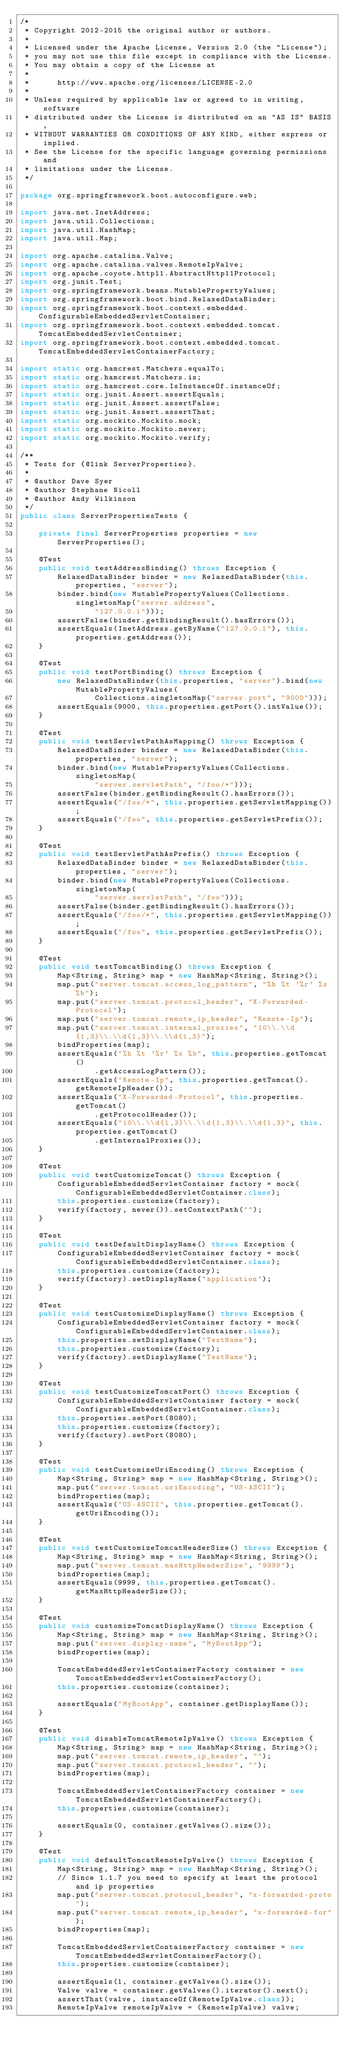Convert code to text. <code><loc_0><loc_0><loc_500><loc_500><_Java_>/*
 * Copyright 2012-2015 the original author or authors.
 *
 * Licensed under the Apache License, Version 2.0 (the "License");
 * you may not use this file except in compliance with the License.
 * You may obtain a copy of the License at
 *
 *      http://www.apache.org/licenses/LICENSE-2.0
 *
 * Unless required by applicable law or agreed to in writing, software
 * distributed under the License is distributed on an "AS IS" BASIS,
 * WITHOUT WARRANTIES OR CONDITIONS OF ANY KIND, either express or implied.
 * See the License for the specific language governing permissions and
 * limitations under the License.
 */

package org.springframework.boot.autoconfigure.web;

import java.net.InetAddress;
import java.util.Collections;
import java.util.HashMap;
import java.util.Map;

import org.apache.catalina.Valve;
import org.apache.catalina.valves.RemoteIpValve;
import org.apache.coyote.http11.AbstractHttp11Protocol;
import org.junit.Test;
import org.springframework.beans.MutablePropertyValues;
import org.springframework.boot.bind.RelaxedDataBinder;
import org.springframework.boot.context.embedded.ConfigurableEmbeddedServletContainer;
import org.springframework.boot.context.embedded.tomcat.TomcatEmbeddedServletContainer;
import org.springframework.boot.context.embedded.tomcat.TomcatEmbeddedServletContainerFactory;

import static org.hamcrest.Matchers.equalTo;
import static org.hamcrest.Matchers.is;
import static org.hamcrest.core.IsInstanceOf.instanceOf;
import static org.junit.Assert.assertEquals;
import static org.junit.Assert.assertFalse;
import static org.junit.Assert.assertThat;
import static org.mockito.Mockito.mock;
import static org.mockito.Mockito.never;
import static org.mockito.Mockito.verify;

/**
 * Tests for {@link ServerProperties}.
 *
 * @author Dave Syer
 * @author Stephane Nicoll
 * @author Andy Wilkinson
 */
public class ServerPropertiesTests {

	private final ServerProperties properties = new ServerProperties();

	@Test
	public void testAddressBinding() throws Exception {
		RelaxedDataBinder binder = new RelaxedDataBinder(this.properties, "server");
		binder.bind(new MutablePropertyValues(Collections.singletonMap("server.address",
				"127.0.0.1")));
		assertFalse(binder.getBindingResult().hasErrors());
		assertEquals(InetAddress.getByName("127.0.0.1"), this.properties.getAddress());
	}

	@Test
	public void testPortBinding() throws Exception {
		new RelaxedDataBinder(this.properties, "server").bind(new MutablePropertyValues(
				Collections.singletonMap("server.port", "9000")));
		assertEquals(9000, this.properties.getPort().intValue());
	}

	@Test
	public void testServletPathAsMapping() throws Exception {
		RelaxedDataBinder binder = new RelaxedDataBinder(this.properties, "server");
		binder.bind(new MutablePropertyValues(Collections.singletonMap(
				"server.servletPath", "/foo/*")));
		assertFalse(binder.getBindingResult().hasErrors());
		assertEquals("/foo/*", this.properties.getServletMapping());
		assertEquals("/foo", this.properties.getServletPrefix());
	}

	@Test
	public void testServletPathAsPrefix() throws Exception {
		RelaxedDataBinder binder = new RelaxedDataBinder(this.properties, "server");
		binder.bind(new MutablePropertyValues(Collections.singletonMap(
				"server.servletPath", "/foo")));
		assertFalse(binder.getBindingResult().hasErrors());
		assertEquals("/foo/*", this.properties.getServletMapping());
		assertEquals("/foo", this.properties.getServletPrefix());
	}

	@Test
	public void testTomcatBinding() throws Exception {
		Map<String, String> map = new HashMap<String, String>();
		map.put("server.tomcat.access_log_pattern", "%h %t '%r' %s %b");
		map.put("server.tomcat.protocol_header", "X-Forwarded-Protocol");
		map.put("server.tomcat.remote_ip_header", "Remote-Ip");
		map.put("server.tomcat.internal_proxies", "10\\.\\d{1,3}\\.\\d{1,3}\\.\\d{1,3}");
		bindProperties(map);
		assertEquals("%h %t '%r' %s %b", this.properties.getTomcat()
				.getAccessLogPattern());
		assertEquals("Remote-Ip", this.properties.getTomcat().getRemoteIpHeader());
		assertEquals("X-Forwarded-Protocol", this.properties.getTomcat()
				.getProtocolHeader());
		assertEquals("10\\.\\d{1,3}\\.\\d{1,3}\\.\\d{1,3}", this.properties.getTomcat()
				.getInternalProxies());
	}

	@Test
	public void testCustomizeTomcat() throws Exception {
		ConfigurableEmbeddedServletContainer factory = mock(ConfigurableEmbeddedServletContainer.class);
		this.properties.customize(factory);
		verify(factory, never()).setContextPath("");
	}

	@Test
	public void testDefaultDisplayName() throws Exception {
		ConfigurableEmbeddedServletContainer factory = mock(ConfigurableEmbeddedServletContainer.class);
		this.properties.customize(factory);
		verify(factory).setDisplayName("application");
	}

	@Test
	public void testCustomizeDisplayName() throws Exception {
		ConfigurableEmbeddedServletContainer factory = mock(ConfigurableEmbeddedServletContainer.class);
		this.properties.setDisplayName("TestName");
		this.properties.customize(factory);
		verify(factory).setDisplayName("TestName");
	}

	@Test
	public void testCustomizeTomcatPort() throws Exception {
		ConfigurableEmbeddedServletContainer factory = mock(ConfigurableEmbeddedServletContainer.class);
		this.properties.setPort(8080);
		this.properties.customize(factory);
		verify(factory).setPort(8080);
	}

	@Test
	public void testCustomizeUriEncoding() throws Exception {
		Map<String, String> map = new HashMap<String, String>();
		map.put("server.tomcat.uriEncoding", "US-ASCII");
		bindProperties(map);
		assertEquals("US-ASCII", this.properties.getTomcat().getUriEncoding());
	}

	@Test
	public void testCustomizeTomcatHeaderSize() throws Exception {
		Map<String, String> map = new HashMap<String, String>();
		map.put("server.tomcat.maxHttpHeaderSize", "9999");
		bindProperties(map);
		assertEquals(9999, this.properties.getTomcat().getMaxHttpHeaderSize());
	}

	@Test
	public void customizeTomcatDisplayName() throws Exception {
		Map<String, String> map = new HashMap<String, String>();
		map.put("server.display-name", "MyBootApp");
		bindProperties(map);

		TomcatEmbeddedServletContainerFactory container = new TomcatEmbeddedServletContainerFactory();
		this.properties.customize(container);

		assertEquals("MyBootApp", container.getDisplayName());
	}

	@Test
	public void disableTomcatRemoteIpValve() throws Exception {
		Map<String, String> map = new HashMap<String, String>();
		map.put("server.tomcat.remote_ip_header", "");
		map.put("server.tomcat.protocol_header", "");
		bindProperties(map);

		TomcatEmbeddedServletContainerFactory container = new TomcatEmbeddedServletContainerFactory();
		this.properties.customize(container);

		assertEquals(0, container.getValves().size());
	}

	@Test
	public void defaultTomcatRemoteIpValve() throws Exception {
		Map<String, String> map = new HashMap<String, String>();
		// Since 1.1.7 you need to specify at least the protocol and ip properties
		map.put("server.tomcat.protocol_header", "x-forwarded-proto");
		map.put("server.tomcat.remote_ip_header", "x-forwarded-for");
		bindProperties(map);

		TomcatEmbeddedServletContainerFactory container = new TomcatEmbeddedServletContainerFactory();
		this.properties.customize(container);

		assertEquals(1, container.getValves().size());
		Valve valve = container.getValves().iterator().next();
		assertThat(valve, instanceOf(RemoteIpValve.class));
		RemoteIpValve remoteIpValve = (RemoteIpValve) valve;</code> 